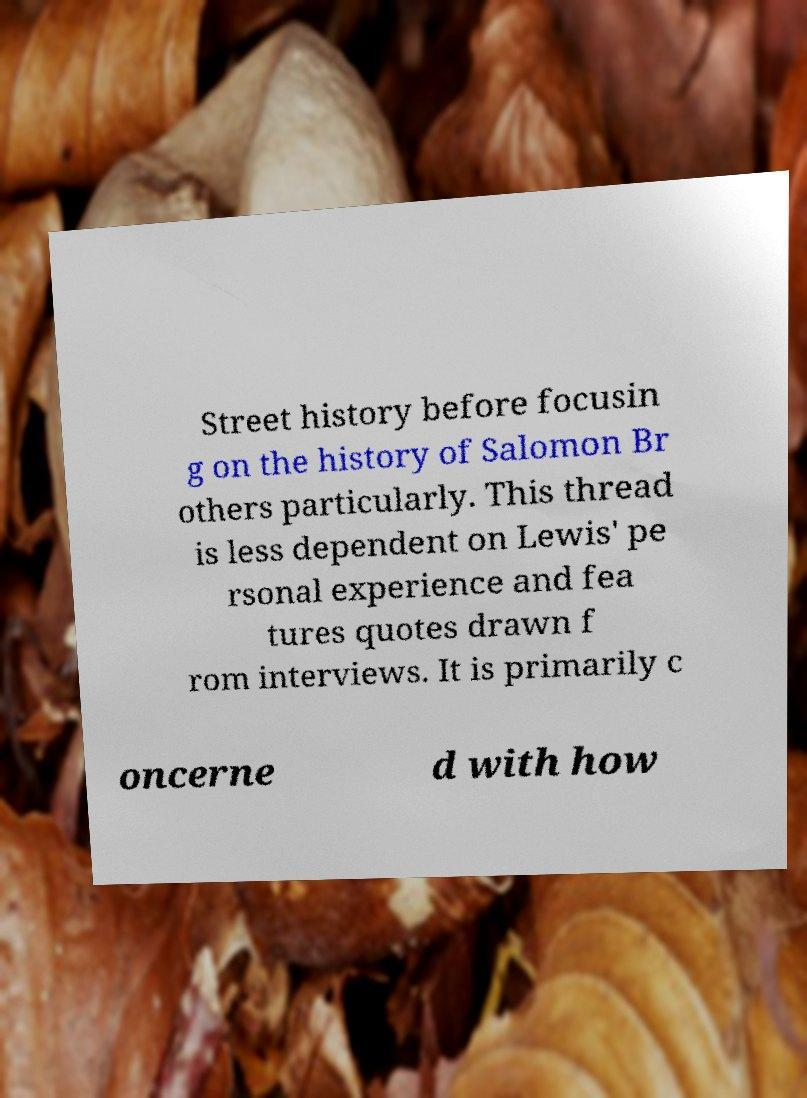Could you assist in decoding the text presented in this image and type it out clearly? Street history before focusin g on the history of Salomon Br others particularly. This thread is less dependent on Lewis' pe rsonal experience and fea tures quotes drawn f rom interviews. It is primarily c oncerne d with how 